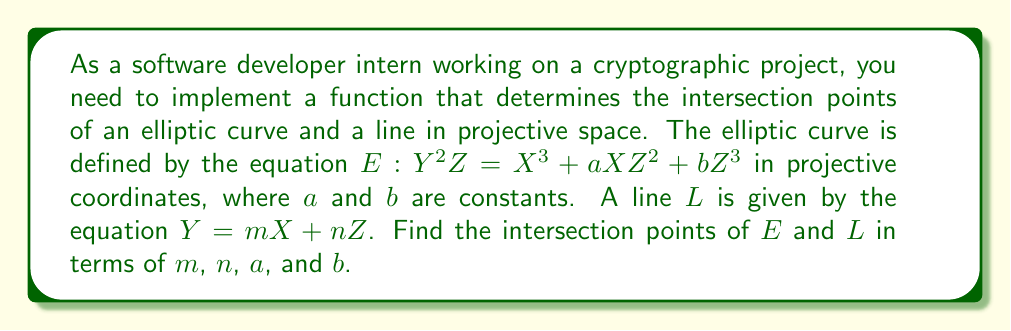Provide a solution to this math problem. To find the intersection points, we'll follow these steps:

1) Substitute the equation of the line into the elliptic curve equation:
   $$(mX + nZ)^2Z = X^3 + aXZ^2 + bZ^3$$

2) Expand the left side:
   $$(m^2X^2 + 2mnXZ + n^2Z^2)Z = X^3 + aXZ^2 + bZ^3$$

3) Rearrange terms:
   $$X^3 - m^2X^2Z + (a-2mn)XZ^2 + (b-n^2)Z^3 = 0$$

4) This is a cubic equation in projective space. To solve it, we can set $Z=1$ (since we're in projective space, we can always do this for at least one of the coordinates):
   $$X^3 - m^2X^2 + (a-2mn)X + (b-n^2) = 0$$

5) This is now a cubic equation in $X$. It will have three roots, corresponding to the three intersection points. The general solution for a cubic equation $Ax^3 + Bx^2 + Cx + D = 0$ is complex, but can be found using Cardano's formula or numerical methods.

6) Once we have the $X$ coordinates, we can find the corresponding $Y$ coordinates using the line equation $Y = mX + n$.

7) The three intersection points in projective coordinates will be:
   $$(X_1 : mX_1 + n : 1)$$
   $$(X_2 : mX_2 + n : 1)$$
   $$(X_3 : mX_3 + n : 1)$$

   where $X_1$, $X_2$, and $X_3$ are the roots of the cubic equation in step 5.
Answer: $(X_i : mX_i + n : 1)$ for $i = 1, 2, 3$, where $X_i$ are roots of $X^3 - m^2X^2 + (a-2mn)X + (b-n^2) = 0$ 